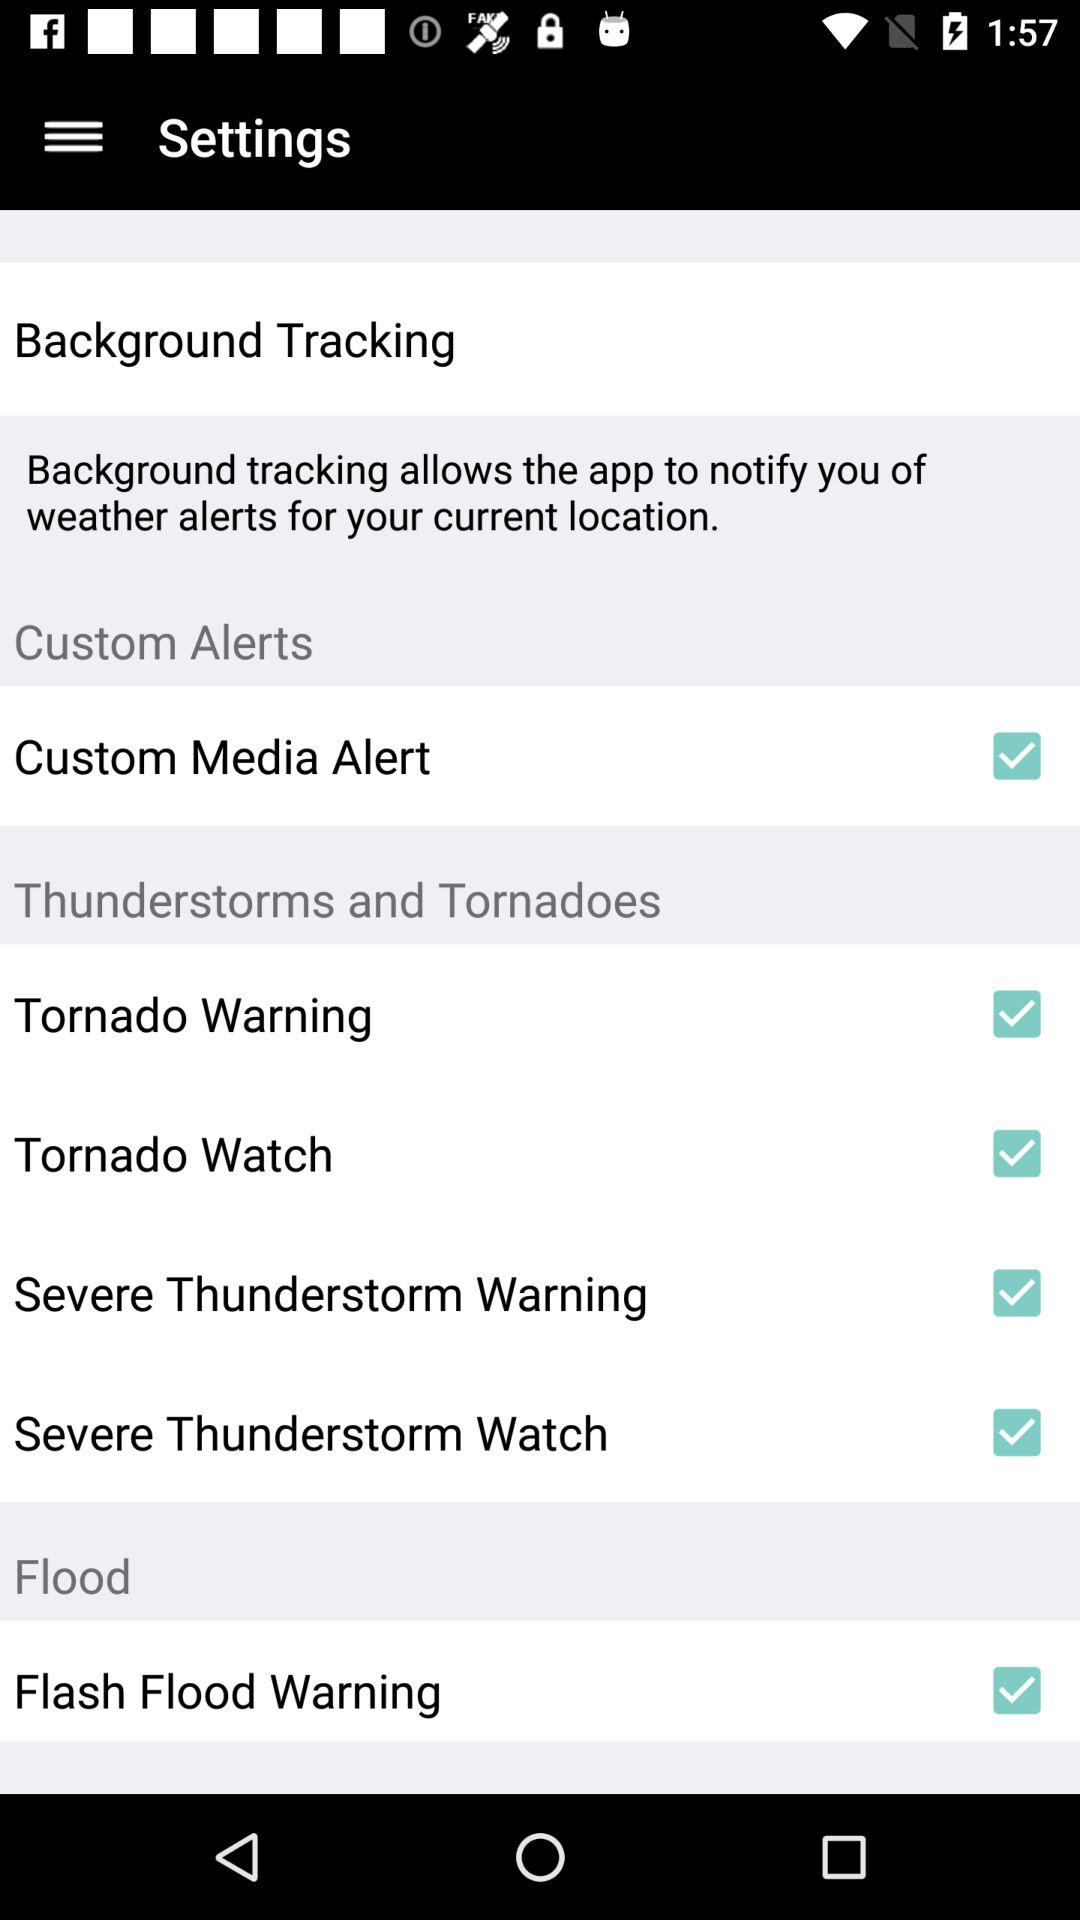What is the status of the "Tornado Warning"? The status of the "Tornado Warning" is "on". 